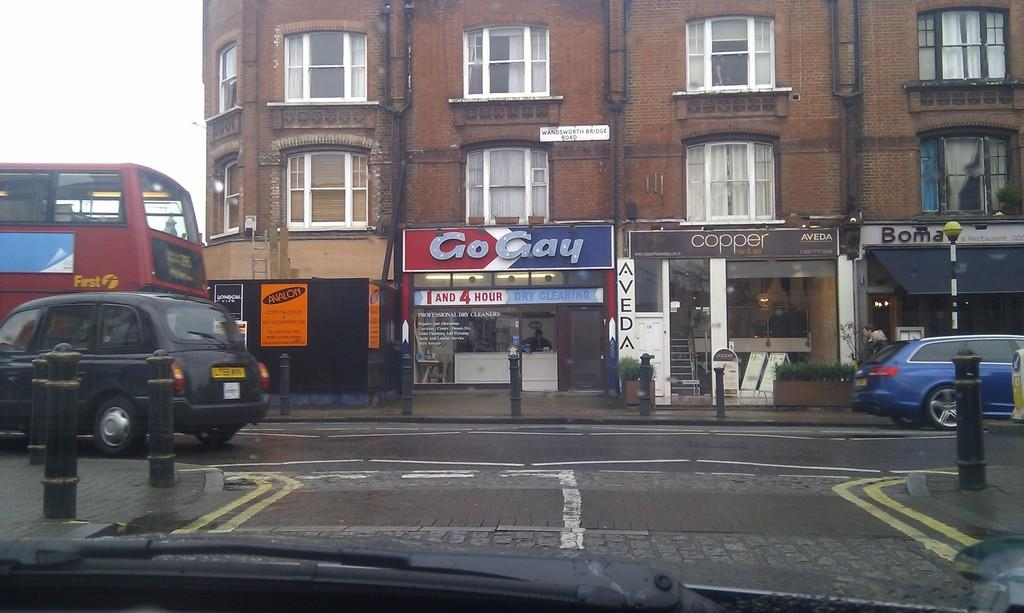<image>
Provide a brief description of the given image. a sign that says Go Gay that is located outside 